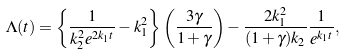Convert formula to latex. <formula><loc_0><loc_0><loc_500><loc_500>\Lambda ( t ) = \left \{ \frac { 1 } { k _ { 2 } ^ { 2 } e ^ { 2 k _ { 1 } t } } - k _ { 1 } ^ { 2 } \right \} \left ( \frac { 3 \gamma } { 1 + \gamma } \right ) - \frac { 2 k _ { 1 } ^ { 2 } } { ( 1 + \gamma ) k _ { 2 } } \frac { 1 } { e ^ { k _ { 1 } t } } ,</formula> 